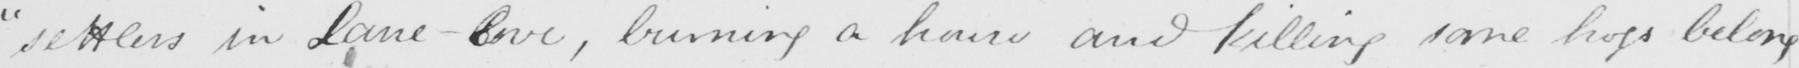Please transcribe the handwritten text in this image. " settlers in Lane-Cove , burning a house and felling some hogs belong- 